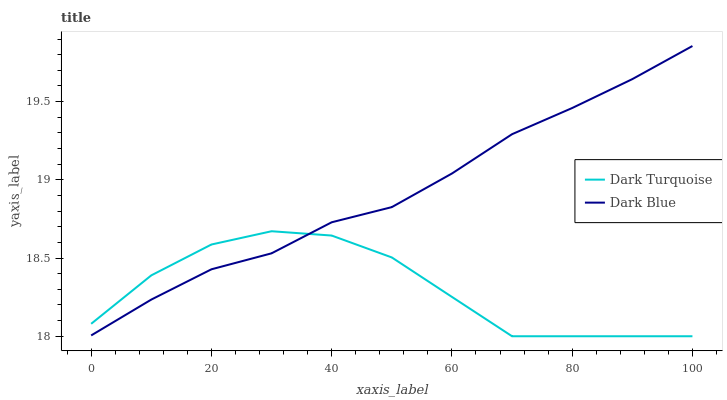Does Dark Turquoise have the minimum area under the curve?
Answer yes or no. Yes. Does Dark Blue have the maximum area under the curve?
Answer yes or no. Yes. Does Dark Blue have the minimum area under the curve?
Answer yes or no. No. Is Dark Blue the smoothest?
Answer yes or no. Yes. Is Dark Turquoise the roughest?
Answer yes or no. Yes. Is Dark Blue the roughest?
Answer yes or no. No. Does Dark Turquoise have the lowest value?
Answer yes or no. Yes. Does Dark Blue have the lowest value?
Answer yes or no. No. Does Dark Blue have the highest value?
Answer yes or no. Yes. Does Dark Blue intersect Dark Turquoise?
Answer yes or no. Yes. Is Dark Blue less than Dark Turquoise?
Answer yes or no. No. Is Dark Blue greater than Dark Turquoise?
Answer yes or no. No. 